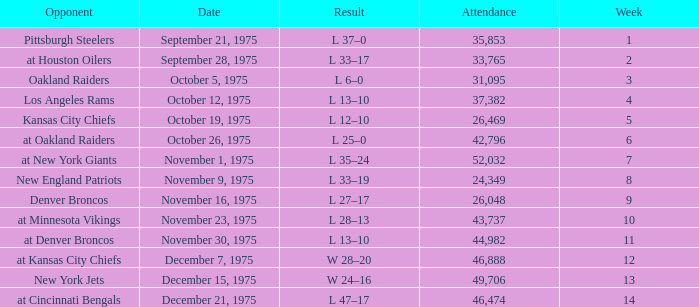What is the highest Week when the opponent was the los angeles rams, with more than 37,382 in Attendance? None. 